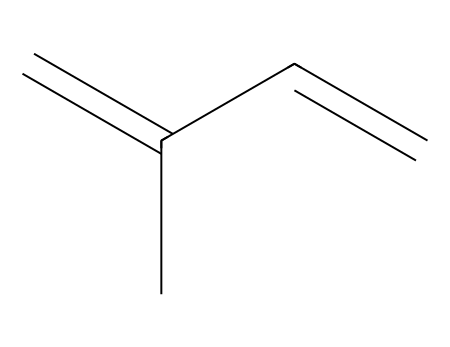What is the common name of the chemical represented by this SMILES? The SMILES representation given, C=C(C)C=C, corresponds to isoprene, which is a well-known monomer in the production of rubber.
Answer: isoprene How many carbon atoms are in this structure? By analyzing the SMILES, there are five carbon atoms in total (C=C(C)C=C corresponds to five carbon units).
Answer: five How many double bonds are present in isoprene? The structure indicates there are two double bonds between carbon atoms, as denoted by the equal signs in the SMILES representation.
Answer: two What type of chemical is isoprene classified as? Isoprene is classified as a diene since it contains two double bonds, a characteristic feature of dienes.
Answer: diene What kind of polymer can be made from isoprene? Isoprene can undergo polymerization to form polyisoprene, which is the main component of natural rubber.
Answer: polyisoprene Which functional groups are not present in isoprene? The structure lacks hydroxyl or carboxyl groups, important functional groups, signified by absence in the SMILES notation provided.
Answer: none Can isoprene participate in addition reactions? Yes, isoprene can participate in addition reactions due to its double bonds, which are sites for such reactions.
Answer: yes 